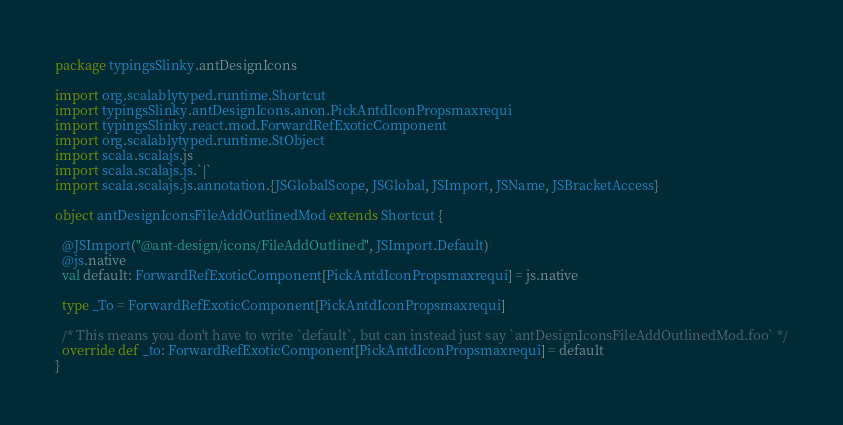<code> <loc_0><loc_0><loc_500><loc_500><_Scala_>package typingsSlinky.antDesignIcons

import org.scalablytyped.runtime.Shortcut
import typingsSlinky.antDesignIcons.anon.PickAntdIconPropsmaxrequi
import typingsSlinky.react.mod.ForwardRefExoticComponent
import org.scalablytyped.runtime.StObject
import scala.scalajs.js
import scala.scalajs.js.`|`
import scala.scalajs.js.annotation.{JSGlobalScope, JSGlobal, JSImport, JSName, JSBracketAccess}

object antDesignIconsFileAddOutlinedMod extends Shortcut {
  
  @JSImport("@ant-design/icons/FileAddOutlined", JSImport.Default)
  @js.native
  val default: ForwardRefExoticComponent[PickAntdIconPropsmaxrequi] = js.native
  
  type _To = ForwardRefExoticComponent[PickAntdIconPropsmaxrequi]
  
  /* This means you don't have to write `default`, but can instead just say `antDesignIconsFileAddOutlinedMod.foo` */
  override def _to: ForwardRefExoticComponent[PickAntdIconPropsmaxrequi] = default
}
</code> 